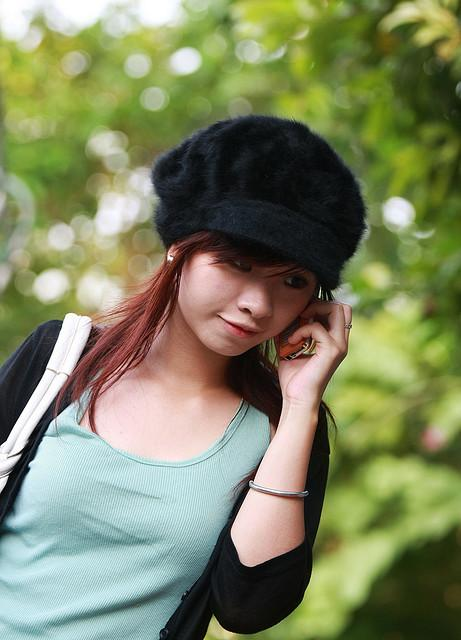Who speaks at this moment? Please explain your reasoning. caller. The caller is talking. 